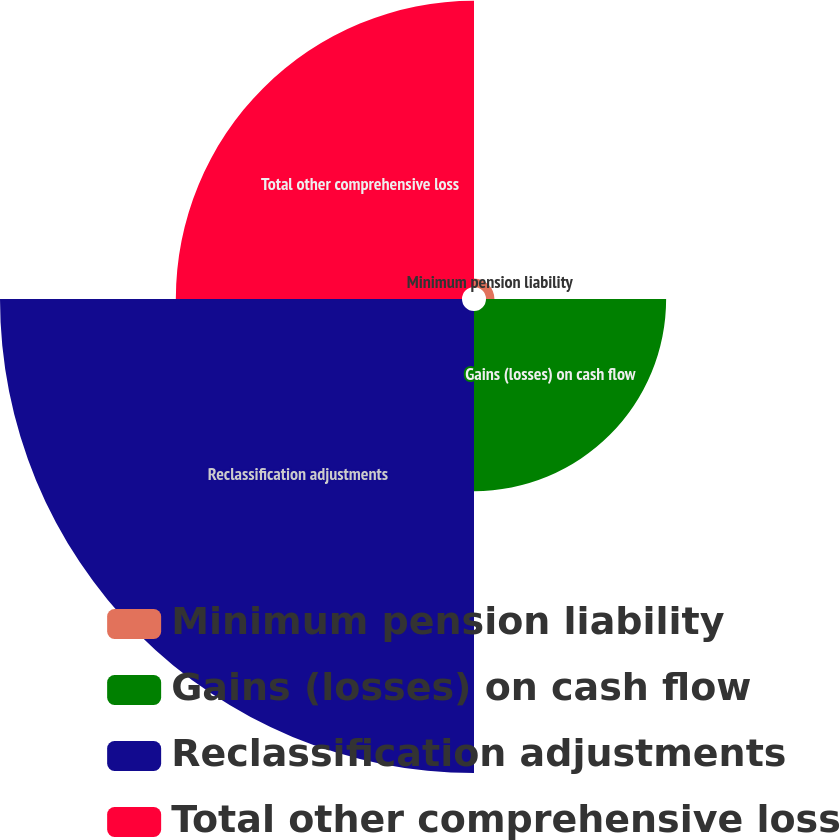Convert chart. <chart><loc_0><loc_0><loc_500><loc_500><pie_chart><fcel>Minimum pension liability<fcel>Gains (losses) on cash flow<fcel>Reclassification adjustments<fcel>Total other comprehensive loss<nl><fcel>0.9%<fcel>19.23%<fcel>49.32%<fcel>30.55%<nl></chart> 